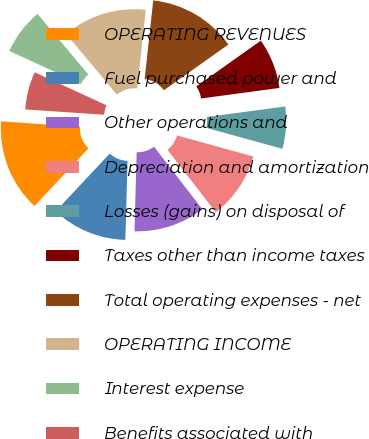<chart> <loc_0><loc_0><loc_500><loc_500><pie_chart><fcel>OPERATING REVENUES<fcel>Fuel purchased power and<fcel>Other operations and<fcel>Depreciation and amortization<fcel>Losses (gains) on disposal of<fcel>Taxes other than income taxes<fcel>Total operating expenses - net<fcel>OPERATING INCOME<fcel>Interest expense<fcel>Benefits associated with<nl><fcel>14.1%<fcel>11.54%<fcel>10.9%<fcel>10.26%<fcel>6.41%<fcel>7.69%<fcel>13.46%<fcel>12.82%<fcel>7.05%<fcel>5.77%<nl></chart> 